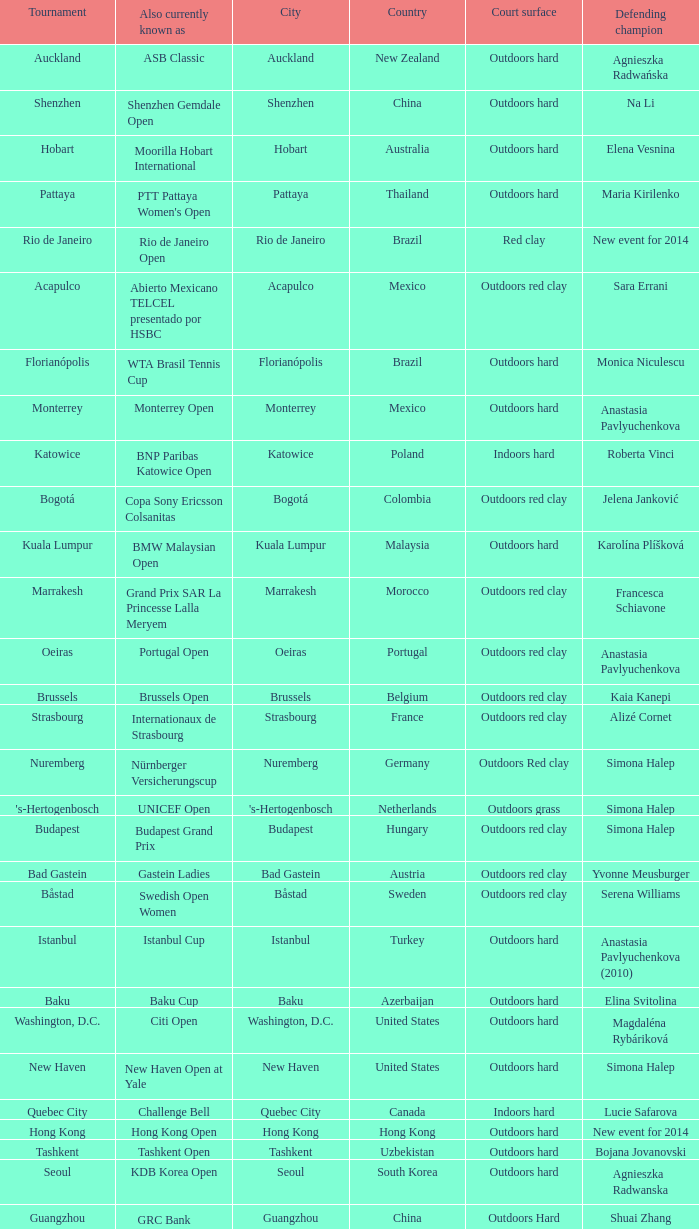Could you parse the entire table? {'header': ['Tournament', 'Also currently known as', 'City', 'Country', 'Court surface', 'Defending champion'], 'rows': [['Auckland', 'ASB Classic', 'Auckland', 'New Zealand', 'Outdoors hard', 'Agnieszka Radwańska'], ['Shenzhen', 'Shenzhen Gemdale Open', 'Shenzhen', 'China', 'Outdoors hard', 'Na Li'], ['Hobart', 'Moorilla Hobart International', 'Hobart', 'Australia', 'Outdoors hard', 'Elena Vesnina'], ['Pattaya', "PTT Pattaya Women's Open", 'Pattaya', 'Thailand', 'Outdoors hard', 'Maria Kirilenko'], ['Rio de Janeiro', 'Rio de Janeiro Open', 'Rio de Janeiro', 'Brazil', 'Red clay', 'New event for 2014'], ['Acapulco', 'Abierto Mexicano TELCEL presentado por HSBC', 'Acapulco', 'Mexico', 'Outdoors red clay', 'Sara Errani'], ['Florianópolis', 'WTA Brasil Tennis Cup', 'Florianópolis', 'Brazil', 'Outdoors hard', 'Monica Niculescu'], ['Monterrey', 'Monterrey Open', 'Monterrey', 'Mexico', 'Outdoors hard', 'Anastasia Pavlyuchenkova'], ['Katowice', 'BNP Paribas Katowice Open', 'Katowice', 'Poland', 'Indoors hard', 'Roberta Vinci'], ['Bogotá', 'Copa Sony Ericsson Colsanitas', 'Bogotá', 'Colombia', 'Outdoors red clay', 'Jelena Janković'], ['Kuala Lumpur', 'BMW Malaysian Open', 'Kuala Lumpur', 'Malaysia', 'Outdoors hard', 'Karolína Plíšková'], ['Marrakesh', 'Grand Prix SAR La Princesse Lalla Meryem', 'Marrakesh', 'Morocco', 'Outdoors red clay', 'Francesca Schiavone'], ['Oeiras', 'Portugal Open', 'Oeiras', 'Portugal', 'Outdoors red clay', 'Anastasia Pavlyuchenkova'], ['Brussels', 'Brussels Open', 'Brussels', 'Belgium', 'Outdoors red clay', 'Kaia Kanepi'], ['Strasbourg', 'Internationaux de Strasbourg', 'Strasbourg', 'France', 'Outdoors red clay', 'Alizé Cornet'], ['Nuremberg', 'Nürnberger Versicherungscup', 'Nuremberg', 'Germany', 'Outdoors Red clay', 'Simona Halep'], ["'s-Hertogenbosch", 'UNICEF Open', "'s-Hertogenbosch", 'Netherlands', 'Outdoors grass', 'Simona Halep'], ['Budapest', 'Budapest Grand Prix', 'Budapest', 'Hungary', 'Outdoors red clay', 'Simona Halep'], ['Bad Gastein', 'Gastein Ladies', 'Bad Gastein', 'Austria', 'Outdoors red clay', 'Yvonne Meusburger'], ['Båstad', 'Swedish Open Women', 'Båstad', 'Sweden', 'Outdoors red clay', 'Serena Williams'], ['Istanbul', 'Istanbul Cup', 'Istanbul', 'Turkey', 'Outdoors hard', 'Anastasia Pavlyuchenkova (2010)'], ['Baku', 'Baku Cup', 'Baku', 'Azerbaijan', 'Outdoors hard', 'Elina Svitolina'], ['Washington, D.C.', 'Citi Open', 'Washington, D.C.', 'United States', 'Outdoors hard', 'Magdaléna Rybáriková'], ['New Haven', 'New Haven Open at Yale', 'New Haven', 'United States', 'Outdoors hard', 'Simona Halep'], ['Quebec City', 'Challenge Bell', 'Quebec City', 'Canada', 'Indoors hard', 'Lucie Safarova'], ['Hong Kong', 'Hong Kong Open', 'Hong Kong', 'Hong Kong', 'Outdoors hard', 'New event for 2014'], ['Tashkent', 'Tashkent Open', 'Tashkent', 'Uzbekistan', 'Outdoors hard', 'Bojana Jovanovski'], ['Seoul', 'KDB Korea Open', 'Seoul', 'South Korea', 'Outdoors hard', 'Agnieszka Radwanska'], ['Guangzhou', "GRC Bank Guangzhou International Women's Open", 'Guangzhou', 'China', 'Outdoors Hard', 'Shuai Zhang'], ['Linz', 'Generali Ladies Linz', 'Linz', 'Austria', 'Indoors hard', 'Angelique Kerber'], ['Osaka', 'HP Open', 'Osaka', 'Japan', 'Outdoors hard', 'Samantha Stosur'], ['Luxembourg', 'BGL Luxembourg Open', 'Luxembourg City', 'Luxembourg', 'Indoors hard', 'Caroline Wozniacki']]} How many competitions are presently recognized as the hp open? 1.0. 